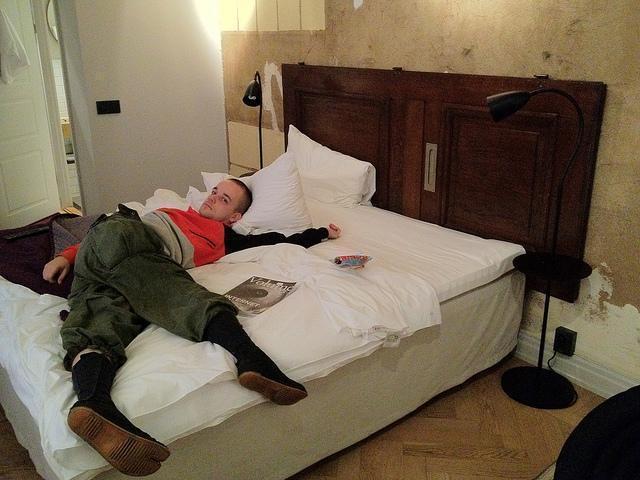What is next to the bed?
Indicate the correct response by choosing from the four available options to answer the question.
Options: Dog, baby, cat, lamp. Lamp. 